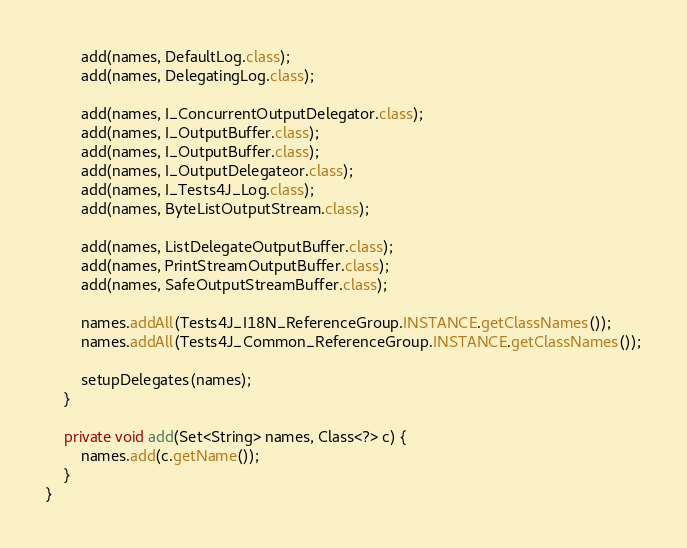Convert code to text. <code><loc_0><loc_0><loc_500><loc_500><_Java_>		add(names, DefaultLog.class);
		add(names, DelegatingLog.class);
		
		add(names, I_ConcurrentOutputDelegator.class);
		add(names, I_OutputBuffer.class);
		add(names, I_OutputBuffer.class);
		add(names, I_OutputDelegateor.class);
		add(names, I_Tests4J_Log.class);
		add(names, ByteListOutputStream.class);
		
		add(names, ListDelegateOutputBuffer.class);
		add(names, PrintStreamOutputBuffer.class);
		add(names, SafeOutputStreamBuffer.class);
		
		names.addAll(Tests4J_I18N_ReferenceGroup.INSTANCE.getClassNames());
		names.addAll(Tests4J_Common_ReferenceGroup.INSTANCE.getClassNames());
		
		setupDelegates(names);
	}
	
	private void add(Set<String> names, Class<?> c) {
		names.add(c.getName());
	}
}
</code> 